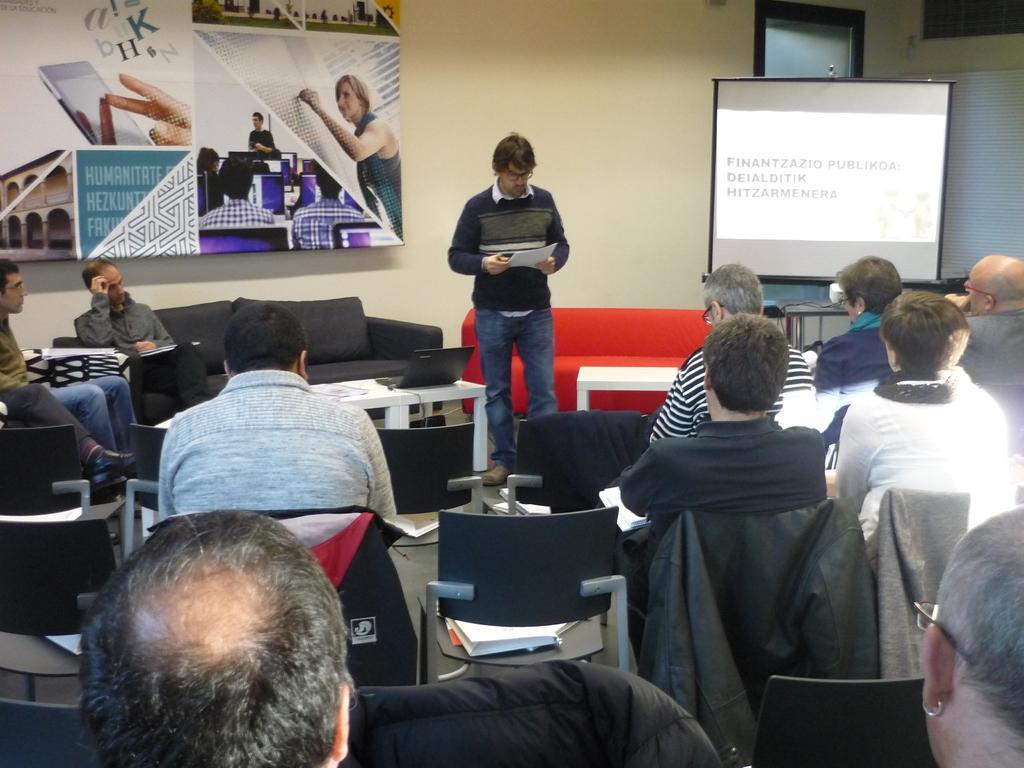How would you summarize this image in a sentence or two? In this image there are some persons sitting in the chairs at bottom of this image. There is one person standing in middle of this image is holding some papers and there is a screen at right side of this image and there is a poster at left side of this image and there is a wall in the background. 